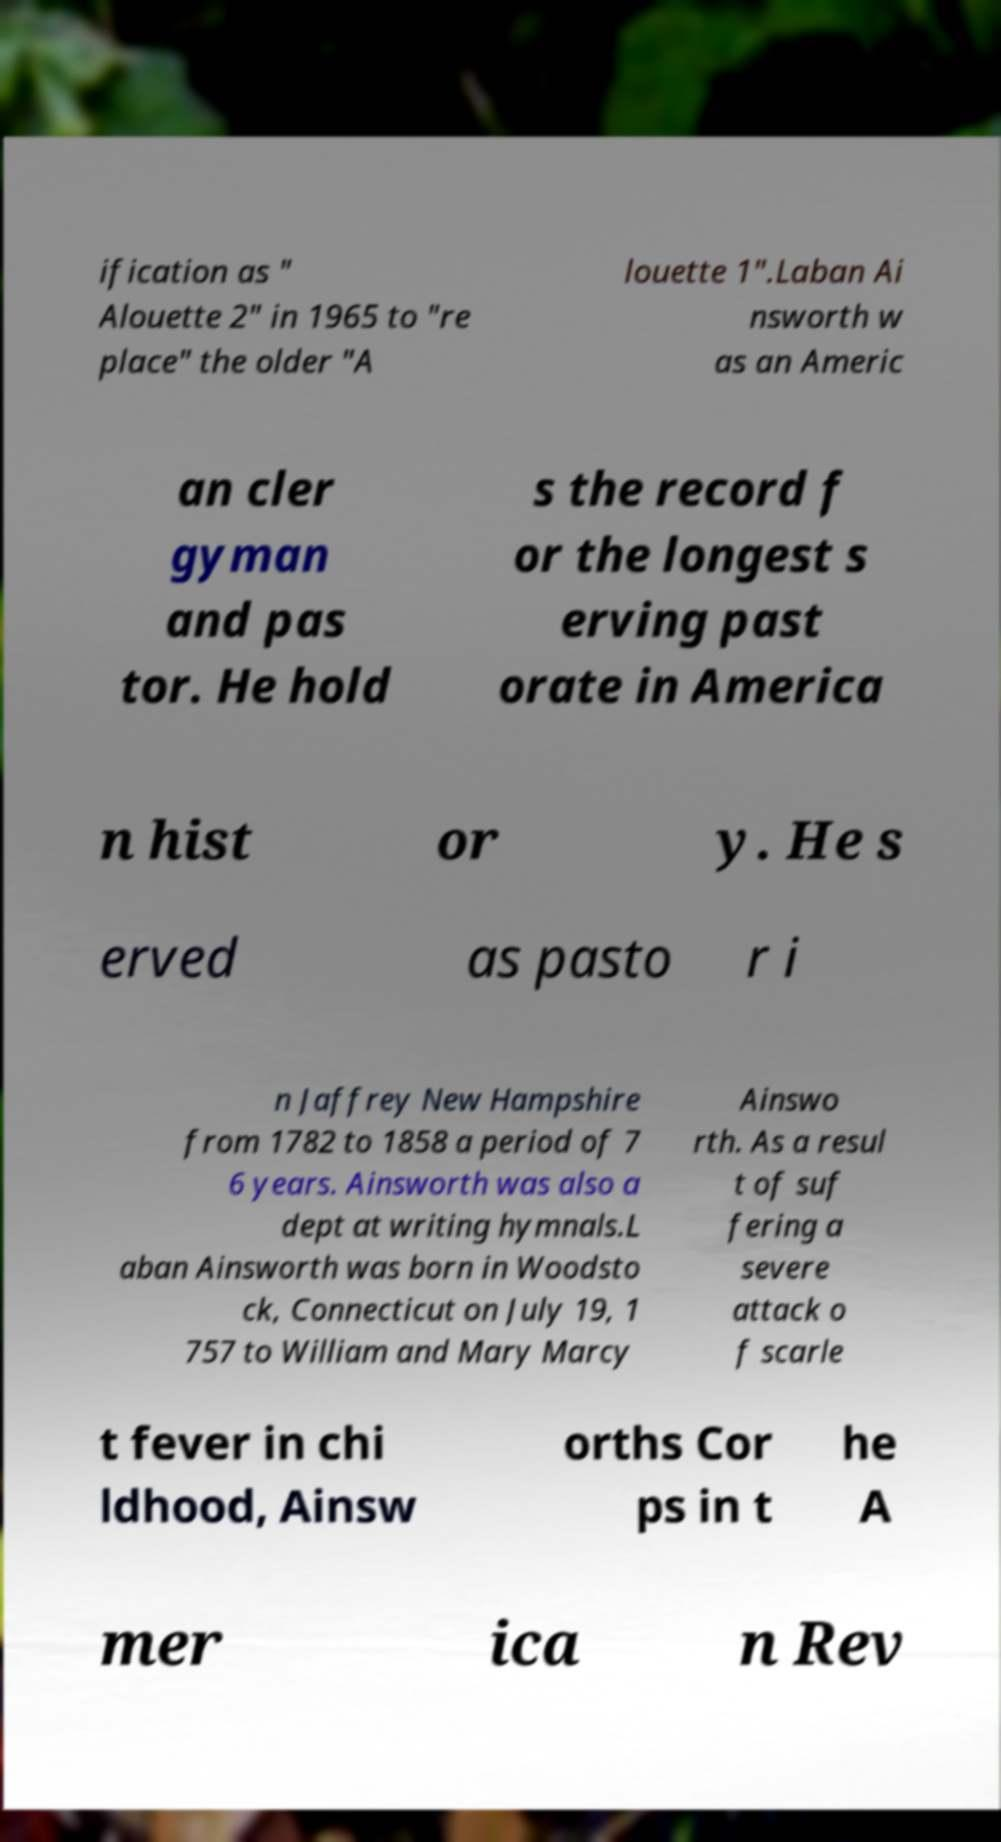I need the written content from this picture converted into text. Can you do that? ification as " Alouette 2" in 1965 to "re place" the older "A louette 1".Laban Ai nsworth w as an Americ an cler gyman and pas tor. He hold s the record f or the longest s erving past orate in America n hist or y. He s erved as pasto r i n Jaffrey New Hampshire from 1782 to 1858 a period of 7 6 years. Ainsworth was also a dept at writing hymnals.L aban Ainsworth was born in Woodsto ck, Connecticut on July 19, 1 757 to William and Mary Marcy Ainswo rth. As a resul t of suf fering a severe attack o f scarle t fever in chi ldhood, Ainsw orths Cor ps in t he A mer ica n Rev 